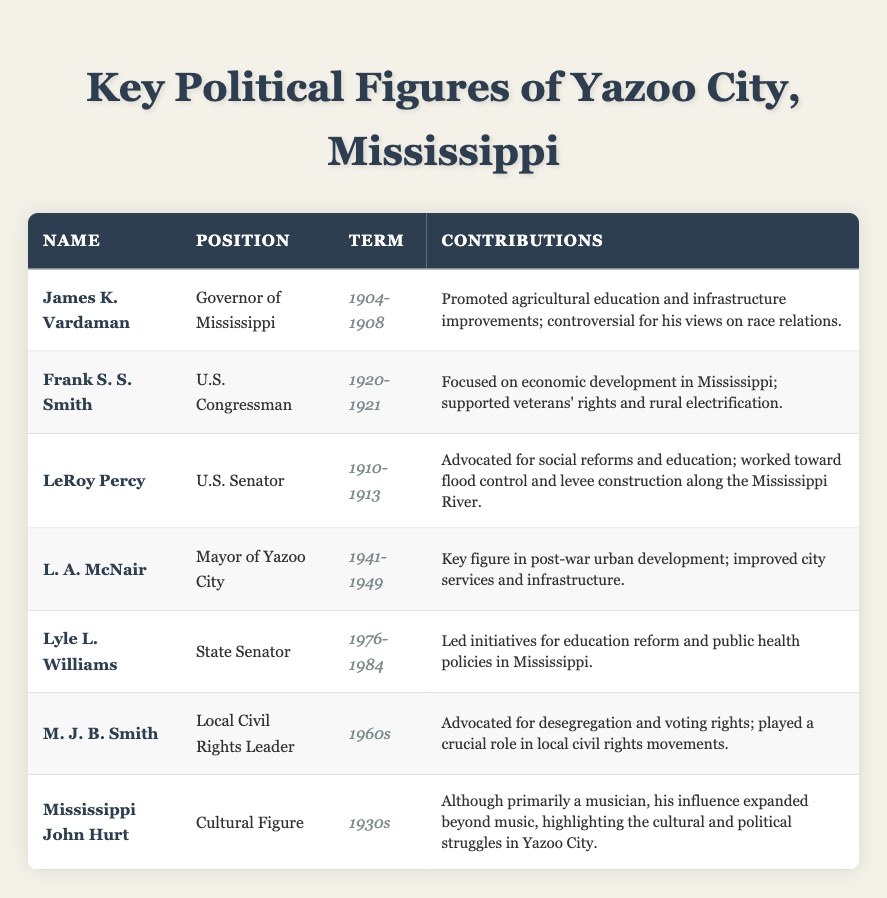What position did L. A. McNair hold? According to the table, L. A. McNair served as the Mayor of Yazoo City.
Answer: Mayor of Yazoo City In what years did James K. Vardaman serve as Governor of Mississippi? The table states that James K. Vardaman's term as Governor was from 1904 to 1908.
Answer: 1904-1908 How many key political figures served in the 1960s? The table lists one figure, M. J. B. Smith, who was a Local Civil Rights Leader during the 1960s.
Answer: 1 What contributions did LeRoy Percy make as U.S. Senator? LeRoy Percy advocated for social reforms and education while also focusing on flood control and levee construction along the Mississippi River.
Answer: Social reforms and flood control Did Frank S. S. Smith serve for more than one term? The table shows that Frank S. S. Smith served only from 1920 to 1921, indicating he did not serve more than one term.
Answer: No Which figure focused on economic development in Mississippi? The table indicates that Frank S. S. Smith focused on economic development in Mississippi during his term as U.S. Congressman.
Answer: Frank S. S. Smith What was the primary focus of Lyle L. Williams during his tenure? According to the table, Lyle L. Williams led initiatives for education reform and public health policies in Mississippi.
Answer: Education reform and public health policies Who had a controversial stance on race relations? The table mentions James K. Vardaman as being controversial for his views on race relations during his governorship.
Answer: James K. Vardaman How many political figures contributed to education reform? There are three figures mentioned: LeRoy Percy, Lyle L. Williams, and James K. Vardaman, who all contributed to education reform.
Answer: 3 What notable contributions did Mississippi John Hurt have? While primarily a musician, the table states that Mississippi John Hurt highlighted cultural and political struggles in Yazoo City, thus influencing beyond music.
Answer: Cultural influence Which political figure served as a local civil rights leader? The table identifies M. J. B. Smith as a Local Civil Rights Leader, who was active during the 1960s.
Answer: M. J. B. Smith 